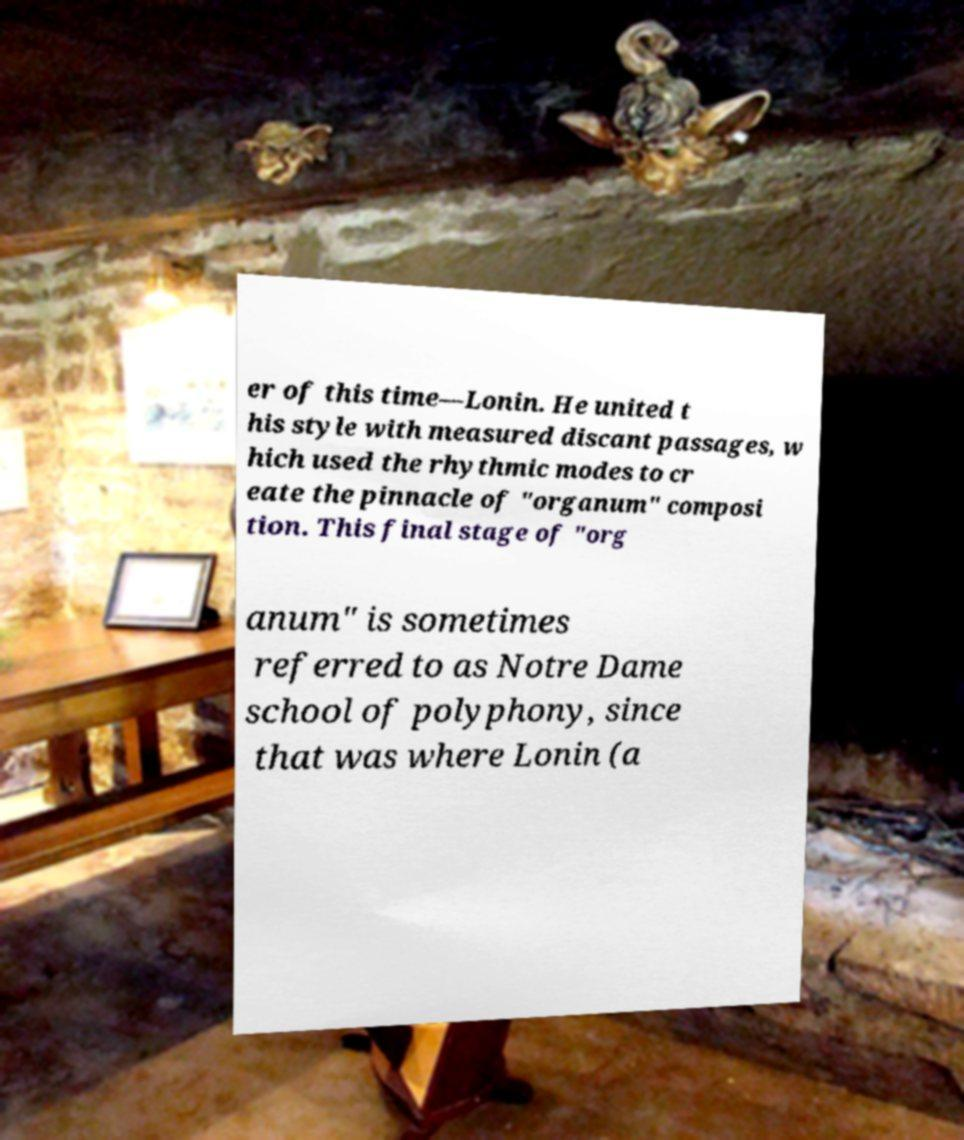Can you accurately transcribe the text from the provided image for me? er of this time—Lonin. He united t his style with measured discant passages, w hich used the rhythmic modes to cr eate the pinnacle of "organum" composi tion. This final stage of "org anum" is sometimes referred to as Notre Dame school of polyphony, since that was where Lonin (a 